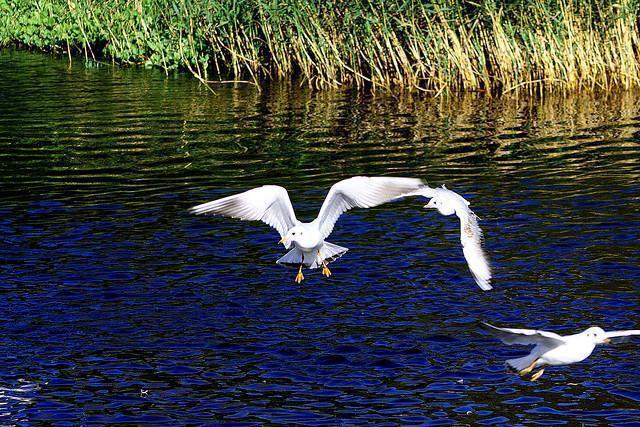What is in the air?
Answer the question by selecting the correct answer among the 4 following choices.
Options: Birds, balloons, kites, airplane. Birds. 